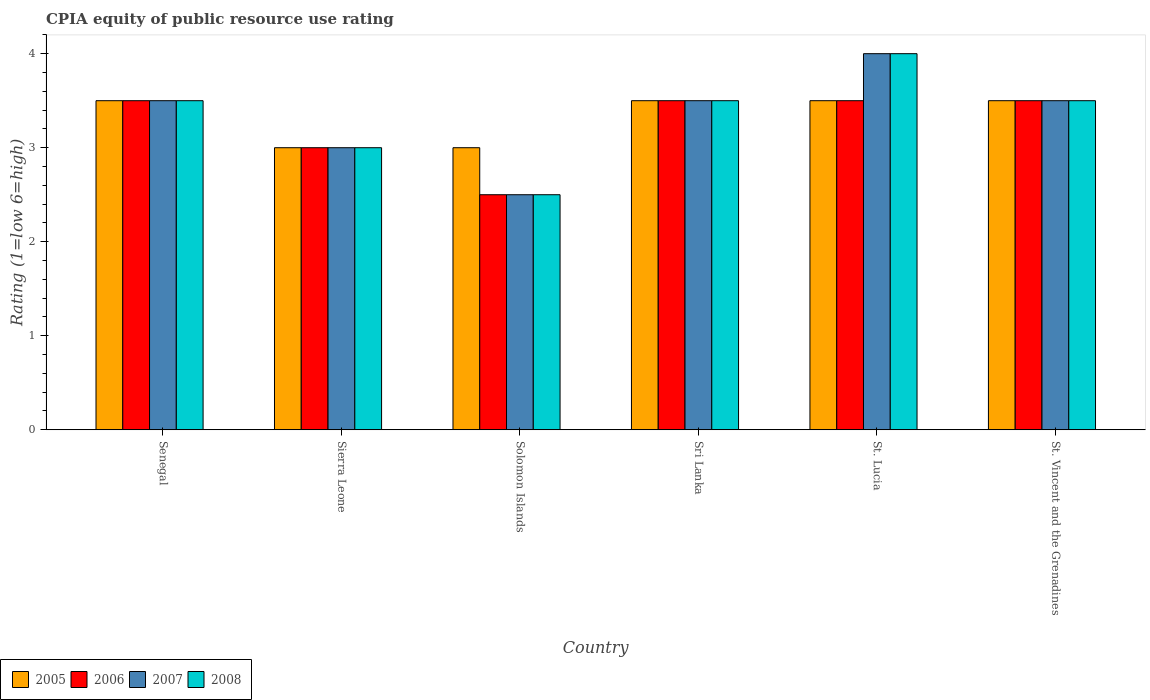How many different coloured bars are there?
Your response must be concise. 4. Are the number of bars per tick equal to the number of legend labels?
Provide a succinct answer. Yes. Are the number of bars on each tick of the X-axis equal?
Offer a terse response. Yes. How many bars are there on the 5th tick from the left?
Ensure brevity in your answer.  4. What is the label of the 6th group of bars from the left?
Give a very brief answer. St. Vincent and the Grenadines. In how many cases, is the number of bars for a given country not equal to the number of legend labels?
Offer a terse response. 0. Across all countries, what is the maximum CPIA rating in 2005?
Provide a short and direct response. 3.5. In which country was the CPIA rating in 2008 maximum?
Your response must be concise. St. Lucia. In which country was the CPIA rating in 2006 minimum?
Your response must be concise. Solomon Islands. What is the difference between the CPIA rating in 2007 in Sri Lanka and the CPIA rating in 2005 in Solomon Islands?
Your answer should be very brief. 0.5. What is the average CPIA rating in 2005 per country?
Make the answer very short. 3.33. What is the ratio of the CPIA rating in 2008 in Solomon Islands to that in Sri Lanka?
Offer a terse response. 0.71. What is the difference between the highest and the lowest CPIA rating in 2006?
Make the answer very short. 1. In how many countries, is the CPIA rating in 2005 greater than the average CPIA rating in 2005 taken over all countries?
Ensure brevity in your answer.  4. What does the 4th bar from the left in Sierra Leone represents?
Provide a succinct answer. 2008. Is it the case that in every country, the sum of the CPIA rating in 2006 and CPIA rating in 2007 is greater than the CPIA rating in 2005?
Provide a succinct answer. Yes. Are all the bars in the graph horizontal?
Give a very brief answer. No. Does the graph contain any zero values?
Your answer should be very brief. No. Does the graph contain grids?
Keep it short and to the point. No. Where does the legend appear in the graph?
Your answer should be very brief. Bottom left. What is the title of the graph?
Make the answer very short. CPIA equity of public resource use rating. What is the Rating (1=low 6=high) of 2005 in Sierra Leone?
Provide a succinct answer. 3. What is the Rating (1=low 6=high) in 2007 in Sierra Leone?
Your response must be concise. 3. What is the Rating (1=low 6=high) in 2008 in Sierra Leone?
Offer a very short reply. 3. What is the Rating (1=low 6=high) in 2005 in Solomon Islands?
Provide a succinct answer. 3. What is the Rating (1=low 6=high) in 2008 in Solomon Islands?
Give a very brief answer. 2.5. What is the Rating (1=low 6=high) of 2005 in Sri Lanka?
Offer a terse response. 3.5. What is the Rating (1=low 6=high) of 2006 in Sri Lanka?
Ensure brevity in your answer.  3.5. What is the Rating (1=low 6=high) of 2008 in Sri Lanka?
Offer a terse response. 3.5. What is the Rating (1=low 6=high) in 2005 in St. Lucia?
Make the answer very short. 3.5. What is the Rating (1=low 6=high) of 2006 in St. Lucia?
Your answer should be compact. 3.5. What is the Rating (1=low 6=high) in 2008 in St. Lucia?
Your answer should be compact. 4. What is the Rating (1=low 6=high) in 2005 in St. Vincent and the Grenadines?
Keep it short and to the point. 3.5. What is the Rating (1=low 6=high) of 2006 in St. Vincent and the Grenadines?
Offer a very short reply. 3.5. What is the Rating (1=low 6=high) of 2007 in St. Vincent and the Grenadines?
Offer a very short reply. 3.5. What is the Rating (1=low 6=high) of 2008 in St. Vincent and the Grenadines?
Make the answer very short. 3.5. Across all countries, what is the maximum Rating (1=low 6=high) of 2008?
Your answer should be very brief. 4. Across all countries, what is the minimum Rating (1=low 6=high) in 2006?
Your answer should be compact. 2.5. What is the total Rating (1=low 6=high) of 2006 in the graph?
Make the answer very short. 19.5. What is the total Rating (1=low 6=high) in 2007 in the graph?
Keep it short and to the point. 20. What is the total Rating (1=low 6=high) in 2008 in the graph?
Your answer should be compact. 20. What is the difference between the Rating (1=low 6=high) of 2005 in Senegal and that in Sierra Leone?
Make the answer very short. 0.5. What is the difference between the Rating (1=low 6=high) in 2008 in Senegal and that in Sierra Leone?
Make the answer very short. 0.5. What is the difference between the Rating (1=low 6=high) of 2006 in Senegal and that in Solomon Islands?
Give a very brief answer. 1. What is the difference between the Rating (1=low 6=high) of 2008 in Senegal and that in Solomon Islands?
Offer a very short reply. 1. What is the difference between the Rating (1=low 6=high) of 2008 in Senegal and that in Sri Lanka?
Provide a short and direct response. 0. What is the difference between the Rating (1=low 6=high) of 2008 in Senegal and that in St. Lucia?
Provide a succinct answer. -0.5. What is the difference between the Rating (1=low 6=high) in 2005 in Senegal and that in St. Vincent and the Grenadines?
Your answer should be compact. 0. What is the difference between the Rating (1=low 6=high) in 2006 in Senegal and that in St. Vincent and the Grenadines?
Provide a short and direct response. 0. What is the difference between the Rating (1=low 6=high) in 2005 in Sierra Leone and that in Solomon Islands?
Your response must be concise. 0. What is the difference between the Rating (1=low 6=high) in 2007 in Sierra Leone and that in Solomon Islands?
Make the answer very short. 0.5. What is the difference between the Rating (1=low 6=high) of 2008 in Sierra Leone and that in Solomon Islands?
Your response must be concise. 0.5. What is the difference between the Rating (1=low 6=high) in 2007 in Sierra Leone and that in Sri Lanka?
Ensure brevity in your answer.  -0.5. What is the difference between the Rating (1=low 6=high) of 2008 in Sierra Leone and that in Sri Lanka?
Ensure brevity in your answer.  -0.5. What is the difference between the Rating (1=low 6=high) in 2007 in Sierra Leone and that in St. Lucia?
Your response must be concise. -1. What is the difference between the Rating (1=low 6=high) of 2005 in Sierra Leone and that in St. Vincent and the Grenadines?
Your answer should be very brief. -0.5. What is the difference between the Rating (1=low 6=high) in 2007 in Sierra Leone and that in St. Vincent and the Grenadines?
Offer a very short reply. -0.5. What is the difference between the Rating (1=low 6=high) in 2007 in Solomon Islands and that in Sri Lanka?
Your response must be concise. -1. What is the difference between the Rating (1=low 6=high) of 2005 in Solomon Islands and that in St. Vincent and the Grenadines?
Provide a short and direct response. -0.5. What is the difference between the Rating (1=low 6=high) in 2006 in Solomon Islands and that in St. Vincent and the Grenadines?
Offer a terse response. -1. What is the difference between the Rating (1=low 6=high) in 2006 in Sri Lanka and that in St. Lucia?
Give a very brief answer. 0. What is the difference between the Rating (1=low 6=high) of 2008 in Sri Lanka and that in St. Lucia?
Give a very brief answer. -0.5. What is the difference between the Rating (1=low 6=high) in 2007 in Sri Lanka and that in St. Vincent and the Grenadines?
Offer a terse response. 0. What is the difference between the Rating (1=low 6=high) of 2005 in Senegal and the Rating (1=low 6=high) of 2008 in Sierra Leone?
Your answer should be compact. 0.5. What is the difference between the Rating (1=low 6=high) in 2005 in Senegal and the Rating (1=low 6=high) in 2007 in Solomon Islands?
Provide a succinct answer. 1. What is the difference between the Rating (1=low 6=high) in 2005 in Senegal and the Rating (1=low 6=high) in 2008 in Solomon Islands?
Offer a very short reply. 1. What is the difference between the Rating (1=low 6=high) of 2006 in Senegal and the Rating (1=low 6=high) of 2007 in Solomon Islands?
Make the answer very short. 1. What is the difference between the Rating (1=low 6=high) of 2006 in Senegal and the Rating (1=low 6=high) of 2008 in Solomon Islands?
Your answer should be compact. 1. What is the difference between the Rating (1=low 6=high) of 2007 in Senegal and the Rating (1=low 6=high) of 2008 in Solomon Islands?
Ensure brevity in your answer.  1. What is the difference between the Rating (1=low 6=high) in 2005 in Senegal and the Rating (1=low 6=high) in 2006 in Sri Lanka?
Your answer should be compact. 0. What is the difference between the Rating (1=low 6=high) of 2005 in Senegal and the Rating (1=low 6=high) of 2007 in Sri Lanka?
Offer a very short reply. 0. What is the difference between the Rating (1=low 6=high) in 2006 in Senegal and the Rating (1=low 6=high) in 2007 in Sri Lanka?
Keep it short and to the point. 0. What is the difference between the Rating (1=low 6=high) in 2005 in Senegal and the Rating (1=low 6=high) in 2006 in St. Lucia?
Provide a succinct answer. 0. What is the difference between the Rating (1=low 6=high) in 2005 in Senegal and the Rating (1=low 6=high) in 2008 in St. Lucia?
Provide a short and direct response. -0.5. What is the difference between the Rating (1=low 6=high) in 2006 in Senegal and the Rating (1=low 6=high) in 2007 in St. Lucia?
Offer a terse response. -0.5. What is the difference between the Rating (1=low 6=high) in 2006 in Senegal and the Rating (1=low 6=high) in 2008 in St. Lucia?
Your response must be concise. -0.5. What is the difference between the Rating (1=low 6=high) of 2007 in Senegal and the Rating (1=low 6=high) of 2008 in St. Lucia?
Offer a terse response. -0.5. What is the difference between the Rating (1=low 6=high) in 2006 in Senegal and the Rating (1=low 6=high) in 2008 in St. Vincent and the Grenadines?
Your response must be concise. 0. What is the difference between the Rating (1=low 6=high) of 2005 in Sierra Leone and the Rating (1=low 6=high) of 2007 in Solomon Islands?
Offer a terse response. 0.5. What is the difference between the Rating (1=low 6=high) of 2005 in Sierra Leone and the Rating (1=low 6=high) of 2008 in Solomon Islands?
Offer a terse response. 0.5. What is the difference between the Rating (1=low 6=high) of 2006 in Sierra Leone and the Rating (1=low 6=high) of 2007 in Solomon Islands?
Provide a succinct answer. 0.5. What is the difference between the Rating (1=low 6=high) in 2005 in Sierra Leone and the Rating (1=low 6=high) in 2006 in Sri Lanka?
Offer a very short reply. -0.5. What is the difference between the Rating (1=low 6=high) of 2005 in Sierra Leone and the Rating (1=low 6=high) of 2007 in Sri Lanka?
Your answer should be very brief. -0.5. What is the difference between the Rating (1=low 6=high) in 2005 in Sierra Leone and the Rating (1=low 6=high) in 2006 in St. Lucia?
Keep it short and to the point. -0.5. What is the difference between the Rating (1=low 6=high) of 2005 in Sierra Leone and the Rating (1=low 6=high) of 2008 in St. Lucia?
Ensure brevity in your answer.  -1. What is the difference between the Rating (1=low 6=high) in 2006 in Sierra Leone and the Rating (1=low 6=high) in 2008 in St. Lucia?
Offer a very short reply. -1. What is the difference between the Rating (1=low 6=high) in 2007 in Sierra Leone and the Rating (1=low 6=high) in 2008 in St. Lucia?
Offer a terse response. -1. What is the difference between the Rating (1=low 6=high) in 2005 in Sierra Leone and the Rating (1=low 6=high) in 2006 in St. Vincent and the Grenadines?
Offer a very short reply. -0.5. What is the difference between the Rating (1=low 6=high) in 2005 in Sierra Leone and the Rating (1=low 6=high) in 2008 in St. Vincent and the Grenadines?
Your response must be concise. -0.5. What is the difference between the Rating (1=low 6=high) in 2006 in Sierra Leone and the Rating (1=low 6=high) in 2008 in St. Vincent and the Grenadines?
Offer a terse response. -0.5. What is the difference between the Rating (1=low 6=high) of 2007 in Sierra Leone and the Rating (1=low 6=high) of 2008 in St. Vincent and the Grenadines?
Your answer should be compact. -0.5. What is the difference between the Rating (1=low 6=high) in 2005 in Solomon Islands and the Rating (1=low 6=high) in 2006 in Sri Lanka?
Provide a succinct answer. -0.5. What is the difference between the Rating (1=low 6=high) of 2005 in Solomon Islands and the Rating (1=low 6=high) of 2007 in Sri Lanka?
Your answer should be very brief. -0.5. What is the difference between the Rating (1=low 6=high) of 2005 in Solomon Islands and the Rating (1=low 6=high) of 2007 in St. Lucia?
Keep it short and to the point. -1. What is the difference between the Rating (1=low 6=high) of 2005 in Solomon Islands and the Rating (1=low 6=high) of 2008 in St. Lucia?
Provide a short and direct response. -1. What is the difference between the Rating (1=low 6=high) of 2006 in Solomon Islands and the Rating (1=low 6=high) of 2007 in St. Lucia?
Give a very brief answer. -1.5. What is the difference between the Rating (1=low 6=high) of 2005 in Solomon Islands and the Rating (1=low 6=high) of 2006 in St. Vincent and the Grenadines?
Your answer should be compact. -0.5. What is the difference between the Rating (1=low 6=high) in 2005 in Sri Lanka and the Rating (1=low 6=high) in 2006 in St. Lucia?
Give a very brief answer. 0. What is the difference between the Rating (1=low 6=high) in 2005 in Sri Lanka and the Rating (1=low 6=high) in 2007 in St. Lucia?
Your answer should be very brief. -0.5. What is the difference between the Rating (1=low 6=high) of 2006 in Sri Lanka and the Rating (1=low 6=high) of 2007 in St. Lucia?
Provide a succinct answer. -0.5. What is the difference between the Rating (1=low 6=high) in 2006 in Sri Lanka and the Rating (1=low 6=high) in 2008 in St. Lucia?
Your answer should be very brief. -0.5. What is the difference between the Rating (1=low 6=high) in 2007 in Sri Lanka and the Rating (1=low 6=high) in 2008 in St. Lucia?
Keep it short and to the point. -0.5. What is the difference between the Rating (1=low 6=high) in 2005 in Sri Lanka and the Rating (1=low 6=high) in 2006 in St. Vincent and the Grenadines?
Offer a very short reply. 0. What is the difference between the Rating (1=low 6=high) of 2005 in Sri Lanka and the Rating (1=low 6=high) of 2007 in St. Vincent and the Grenadines?
Give a very brief answer. 0. What is the difference between the Rating (1=low 6=high) of 2005 in Sri Lanka and the Rating (1=low 6=high) of 2008 in St. Vincent and the Grenadines?
Offer a very short reply. 0. What is the difference between the Rating (1=low 6=high) of 2006 in Sri Lanka and the Rating (1=low 6=high) of 2007 in St. Vincent and the Grenadines?
Your answer should be compact. 0. What is the difference between the Rating (1=low 6=high) of 2006 in Sri Lanka and the Rating (1=low 6=high) of 2008 in St. Vincent and the Grenadines?
Offer a very short reply. 0. What is the difference between the Rating (1=low 6=high) of 2007 in Sri Lanka and the Rating (1=low 6=high) of 2008 in St. Vincent and the Grenadines?
Provide a succinct answer. 0. What is the difference between the Rating (1=low 6=high) of 2005 in St. Lucia and the Rating (1=low 6=high) of 2006 in St. Vincent and the Grenadines?
Make the answer very short. 0. What is the difference between the Rating (1=low 6=high) in 2005 in St. Lucia and the Rating (1=low 6=high) in 2007 in St. Vincent and the Grenadines?
Your response must be concise. 0. What is the difference between the Rating (1=low 6=high) in 2005 in St. Lucia and the Rating (1=low 6=high) in 2008 in St. Vincent and the Grenadines?
Your response must be concise. 0. What is the difference between the Rating (1=low 6=high) of 2006 in St. Lucia and the Rating (1=low 6=high) of 2007 in St. Vincent and the Grenadines?
Make the answer very short. 0. What is the average Rating (1=low 6=high) of 2005 per country?
Keep it short and to the point. 3.33. What is the average Rating (1=low 6=high) in 2006 per country?
Offer a very short reply. 3.25. What is the average Rating (1=low 6=high) of 2007 per country?
Keep it short and to the point. 3.33. What is the average Rating (1=low 6=high) of 2008 per country?
Your response must be concise. 3.33. What is the difference between the Rating (1=low 6=high) of 2005 and Rating (1=low 6=high) of 2007 in Senegal?
Ensure brevity in your answer.  0. What is the difference between the Rating (1=low 6=high) in 2006 and Rating (1=low 6=high) in 2007 in Senegal?
Keep it short and to the point. 0. What is the difference between the Rating (1=low 6=high) in 2007 and Rating (1=low 6=high) in 2008 in Senegal?
Give a very brief answer. 0. What is the difference between the Rating (1=low 6=high) in 2005 and Rating (1=low 6=high) in 2006 in Sierra Leone?
Keep it short and to the point. 0. What is the difference between the Rating (1=low 6=high) of 2005 and Rating (1=low 6=high) of 2008 in Sierra Leone?
Provide a short and direct response. 0. What is the difference between the Rating (1=low 6=high) of 2006 and Rating (1=low 6=high) of 2007 in Sierra Leone?
Your answer should be compact. 0. What is the difference between the Rating (1=low 6=high) in 2006 and Rating (1=low 6=high) in 2008 in Sierra Leone?
Make the answer very short. 0. What is the difference between the Rating (1=low 6=high) of 2007 and Rating (1=low 6=high) of 2008 in Sierra Leone?
Make the answer very short. 0. What is the difference between the Rating (1=low 6=high) in 2005 and Rating (1=low 6=high) in 2006 in Solomon Islands?
Offer a terse response. 0.5. What is the difference between the Rating (1=low 6=high) in 2005 and Rating (1=low 6=high) in 2007 in Solomon Islands?
Keep it short and to the point. 0.5. What is the difference between the Rating (1=low 6=high) of 2005 and Rating (1=low 6=high) of 2008 in Solomon Islands?
Offer a terse response. 0.5. What is the difference between the Rating (1=low 6=high) of 2005 and Rating (1=low 6=high) of 2006 in Sri Lanka?
Ensure brevity in your answer.  0. What is the difference between the Rating (1=low 6=high) of 2006 and Rating (1=low 6=high) of 2007 in Sri Lanka?
Give a very brief answer. 0. What is the difference between the Rating (1=low 6=high) in 2006 and Rating (1=low 6=high) in 2008 in St. Lucia?
Provide a succinct answer. -0.5. What is the difference between the Rating (1=low 6=high) of 2007 and Rating (1=low 6=high) of 2008 in St. Lucia?
Make the answer very short. 0. What is the difference between the Rating (1=low 6=high) in 2005 and Rating (1=low 6=high) in 2006 in St. Vincent and the Grenadines?
Offer a very short reply. 0. What is the difference between the Rating (1=low 6=high) of 2005 and Rating (1=low 6=high) of 2007 in St. Vincent and the Grenadines?
Your response must be concise. 0. What is the difference between the Rating (1=low 6=high) in 2005 and Rating (1=low 6=high) in 2008 in St. Vincent and the Grenadines?
Give a very brief answer. 0. What is the difference between the Rating (1=low 6=high) in 2007 and Rating (1=low 6=high) in 2008 in St. Vincent and the Grenadines?
Your response must be concise. 0. What is the ratio of the Rating (1=low 6=high) of 2006 in Senegal to that in Sierra Leone?
Offer a very short reply. 1.17. What is the ratio of the Rating (1=low 6=high) of 2007 in Senegal to that in Sierra Leone?
Give a very brief answer. 1.17. What is the ratio of the Rating (1=low 6=high) of 2008 in Senegal to that in Sierra Leone?
Your answer should be very brief. 1.17. What is the ratio of the Rating (1=low 6=high) in 2005 in Senegal to that in Solomon Islands?
Give a very brief answer. 1.17. What is the ratio of the Rating (1=low 6=high) of 2005 in Senegal to that in St. Vincent and the Grenadines?
Make the answer very short. 1. What is the ratio of the Rating (1=low 6=high) of 2006 in Senegal to that in St. Vincent and the Grenadines?
Keep it short and to the point. 1. What is the ratio of the Rating (1=low 6=high) in 2006 in Sierra Leone to that in Solomon Islands?
Provide a short and direct response. 1.2. What is the ratio of the Rating (1=low 6=high) in 2005 in Sierra Leone to that in Sri Lanka?
Your answer should be very brief. 0.86. What is the ratio of the Rating (1=low 6=high) in 2006 in Sierra Leone to that in Sri Lanka?
Ensure brevity in your answer.  0.86. What is the ratio of the Rating (1=low 6=high) in 2005 in Sierra Leone to that in St. Lucia?
Your response must be concise. 0.86. What is the ratio of the Rating (1=low 6=high) in 2007 in Sierra Leone to that in St. Lucia?
Offer a very short reply. 0.75. What is the ratio of the Rating (1=low 6=high) of 2008 in Sierra Leone to that in St. Lucia?
Your response must be concise. 0.75. What is the ratio of the Rating (1=low 6=high) in 2006 in Sierra Leone to that in St. Vincent and the Grenadines?
Offer a terse response. 0.86. What is the ratio of the Rating (1=low 6=high) of 2007 in Sierra Leone to that in St. Vincent and the Grenadines?
Your answer should be very brief. 0.86. What is the ratio of the Rating (1=low 6=high) in 2008 in Sierra Leone to that in St. Vincent and the Grenadines?
Make the answer very short. 0.86. What is the ratio of the Rating (1=low 6=high) in 2005 in Solomon Islands to that in Sri Lanka?
Ensure brevity in your answer.  0.86. What is the ratio of the Rating (1=low 6=high) of 2007 in Solomon Islands to that in Sri Lanka?
Offer a terse response. 0.71. What is the ratio of the Rating (1=low 6=high) of 2005 in Solomon Islands to that in St. Lucia?
Keep it short and to the point. 0.86. What is the ratio of the Rating (1=low 6=high) in 2006 in Solomon Islands to that in St. Lucia?
Offer a very short reply. 0.71. What is the ratio of the Rating (1=low 6=high) in 2008 in Solomon Islands to that in St. Lucia?
Provide a short and direct response. 0.62. What is the ratio of the Rating (1=low 6=high) of 2005 in Solomon Islands to that in St. Vincent and the Grenadines?
Your answer should be very brief. 0.86. What is the ratio of the Rating (1=low 6=high) of 2006 in Solomon Islands to that in St. Vincent and the Grenadines?
Make the answer very short. 0.71. What is the ratio of the Rating (1=low 6=high) of 2007 in Solomon Islands to that in St. Vincent and the Grenadines?
Your answer should be compact. 0.71. What is the ratio of the Rating (1=low 6=high) in 2008 in Sri Lanka to that in St. Lucia?
Your response must be concise. 0.88. What is the ratio of the Rating (1=low 6=high) in 2006 in Sri Lanka to that in St. Vincent and the Grenadines?
Make the answer very short. 1. What is the ratio of the Rating (1=low 6=high) of 2005 in St. Lucia to that in St. Vincent and the Grenadines?
Offer a very short reply. 1. What is the ratio of the Rating (1=low 6=high) in 2006 in St. Lucia to that in St. Vincent and the Grenadines?
Provide a short and direct response. 1. What is the ratio of the Rating (1=low 6=high) of 2007 in St. Lucia to that in St. Vincent and the Grenadines?
Your response must be concise. 1.14. What is the ratio of the Rating (1=low 6=high) in 2008 in St. Lucia to that in St. Vincent and the Grenadines?
Keep it short and to the point. 1.14. What is the difference between the highest and the second highest Rating (1=low 6=high) in 2005?
Your answer should be compact. 0. What is the difference between the highest and the second highest Rating (1=low 6=high) in 2007?
Offer a terse response. 0.5. What is the difference between the highest and the lowest Rating (1=low 6=high) in 2007?
Provide a succinct answer. 1.5. 